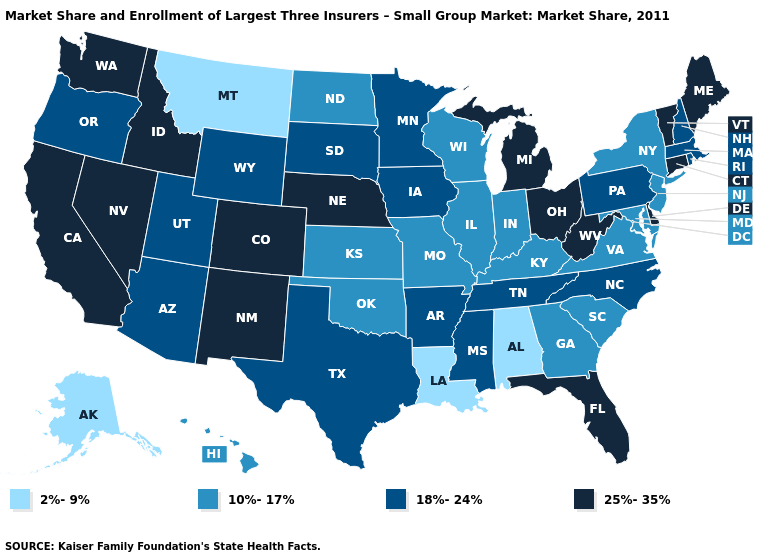What is the value of New Hampshire?
Give a very brief answer. 18%-24%. How many symbols are there in the legend?
Keep it brief. 4. What is the value of Alaska?
Be succinct. 2%-9%. How many symbols are there in the legend?
Quick response, please. 4. Which states have the lowest value in the West?
Be succinct. Alaska, Montana. What is the highest value in states that border Nebraska?
Keep it brief. 25%-35%. Does Virginia have a lower value than Iowa?
Keep it brief. Yes. What is the value of New Hampshire?
Concise answer only. 18%-24%. What is the value of Iowa?
Concise answer only. 18%-24%. Which states hav the highest value in the MidWest?
Concise answer only. Michigan, Nebraska, Ohio. What is the highest value in states that border Wyoming?
Be succinct. 25%-35%. What is the highest value in the Northeast ?
Answer briefly. 25%-35%. Name the states that have a value in the range 2%-9%?
Short answer required. Alabama, Alaska, Louisiana, Montana. What is the value of Arizona?
Give a very brief answer. 18%-24%. What is the value of Arkansas?
Answer briefly. 18%-24%. 